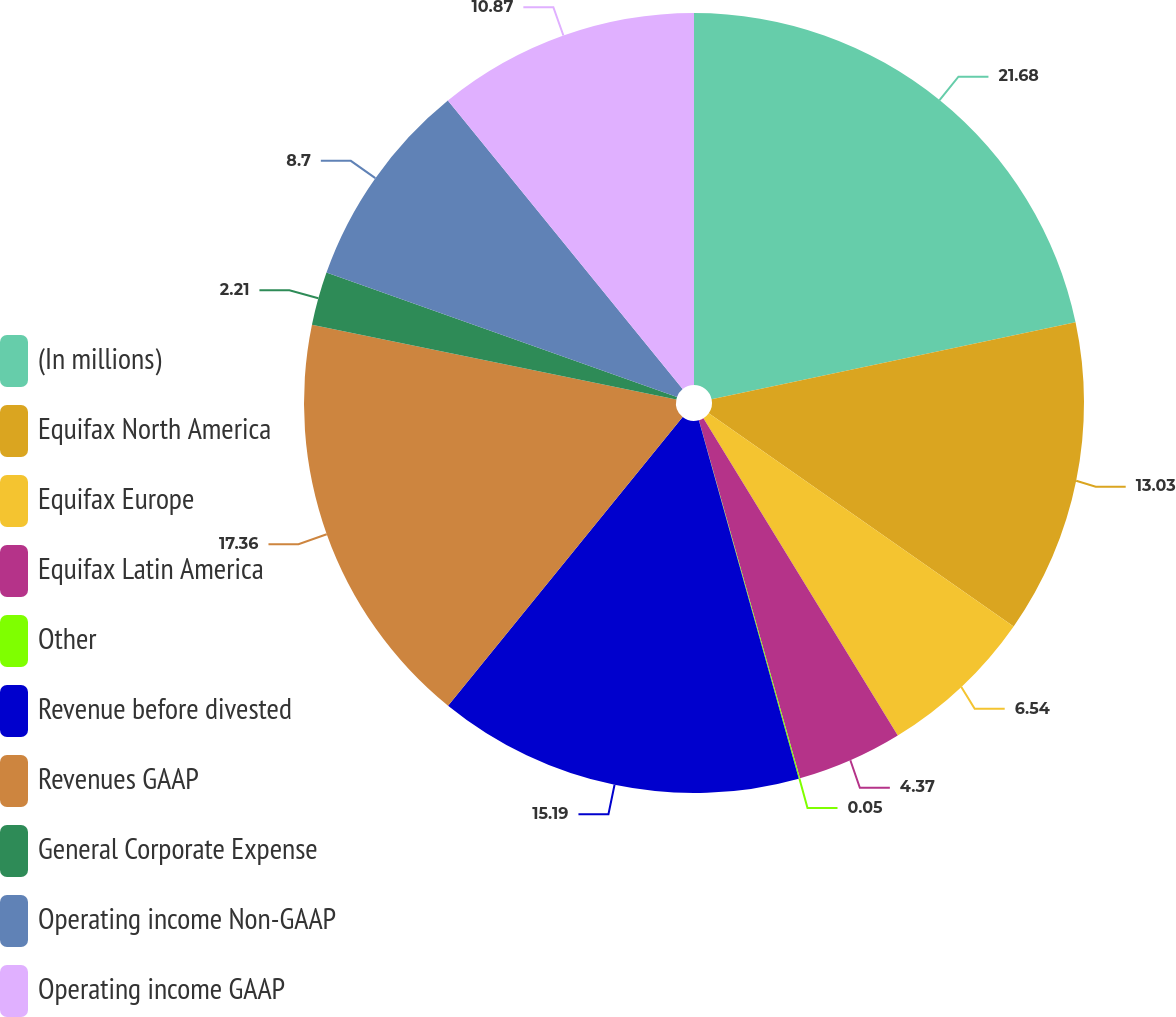<chart> <loc_0><loc_0><loc_500><loc_500><pie_chart><fcel>(In millions)<fcel>Equifax North America<fcel>Equifax Europe<fcel>Equifax Latin America<fcel>Other<fcel>Revenue before divested<fcel>Revenues GAAP<fcel>General Corporate Expense<fcel>Operating income Non-GAAP<fcel>Operating income GAAP<nl><fcel>21.68%<fcel>13.03%<fcel>6.54%<fcel>4.37%<fcel>0.05%<fcel>15.19%<fcel>17.36%<fcel>2.21%<fcel>8.7%<fcel>10.87%<nl></chart> 